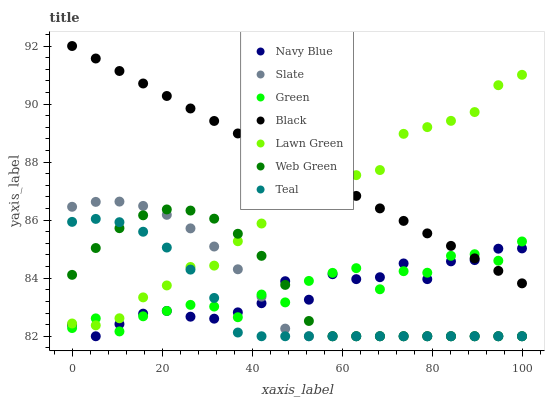Does Teal have the minimum area under the curve?
Answer yes or no. Yes. Does Black have the maximum area under the curve?
Answer yes or no. Yes. Does Navy Blue have the minimum area under the curve?
Answer yes or no. No. Does Navy Blue have the maximum area under the curve?
Answer yes or no. No. Is Black the smoothest?
Answer yes or no. Yes. Is Green the roughest?
Answer yes or no. Yes. Is Navy Blue the smoothest?
Answer yes or no. No. Is Navy Blue the roughest?
Answer yes or no. No. Does Navy Blue have the lowest value?
Answer yes or no. Yes. Does Green have the lowest value?
Answer yes or no. No. Does Black have the highest value?
Answer yes or no. Yes. Does Slate have the highest value?
Answer yes or no. No. Is Slate less than Black?
Answer yes or no. Yes. Is Black greater than Slate?
Answer yes or no. Yes. Does Teal intersect Web Green?
Answer yes or no. Yes. Is Teal less than Web Green?
Answer yes or no. No. Is Teal greater than Web Green?
Answer yes or no. No. Does Slate intersect Black?
Answer yes or no. No. 